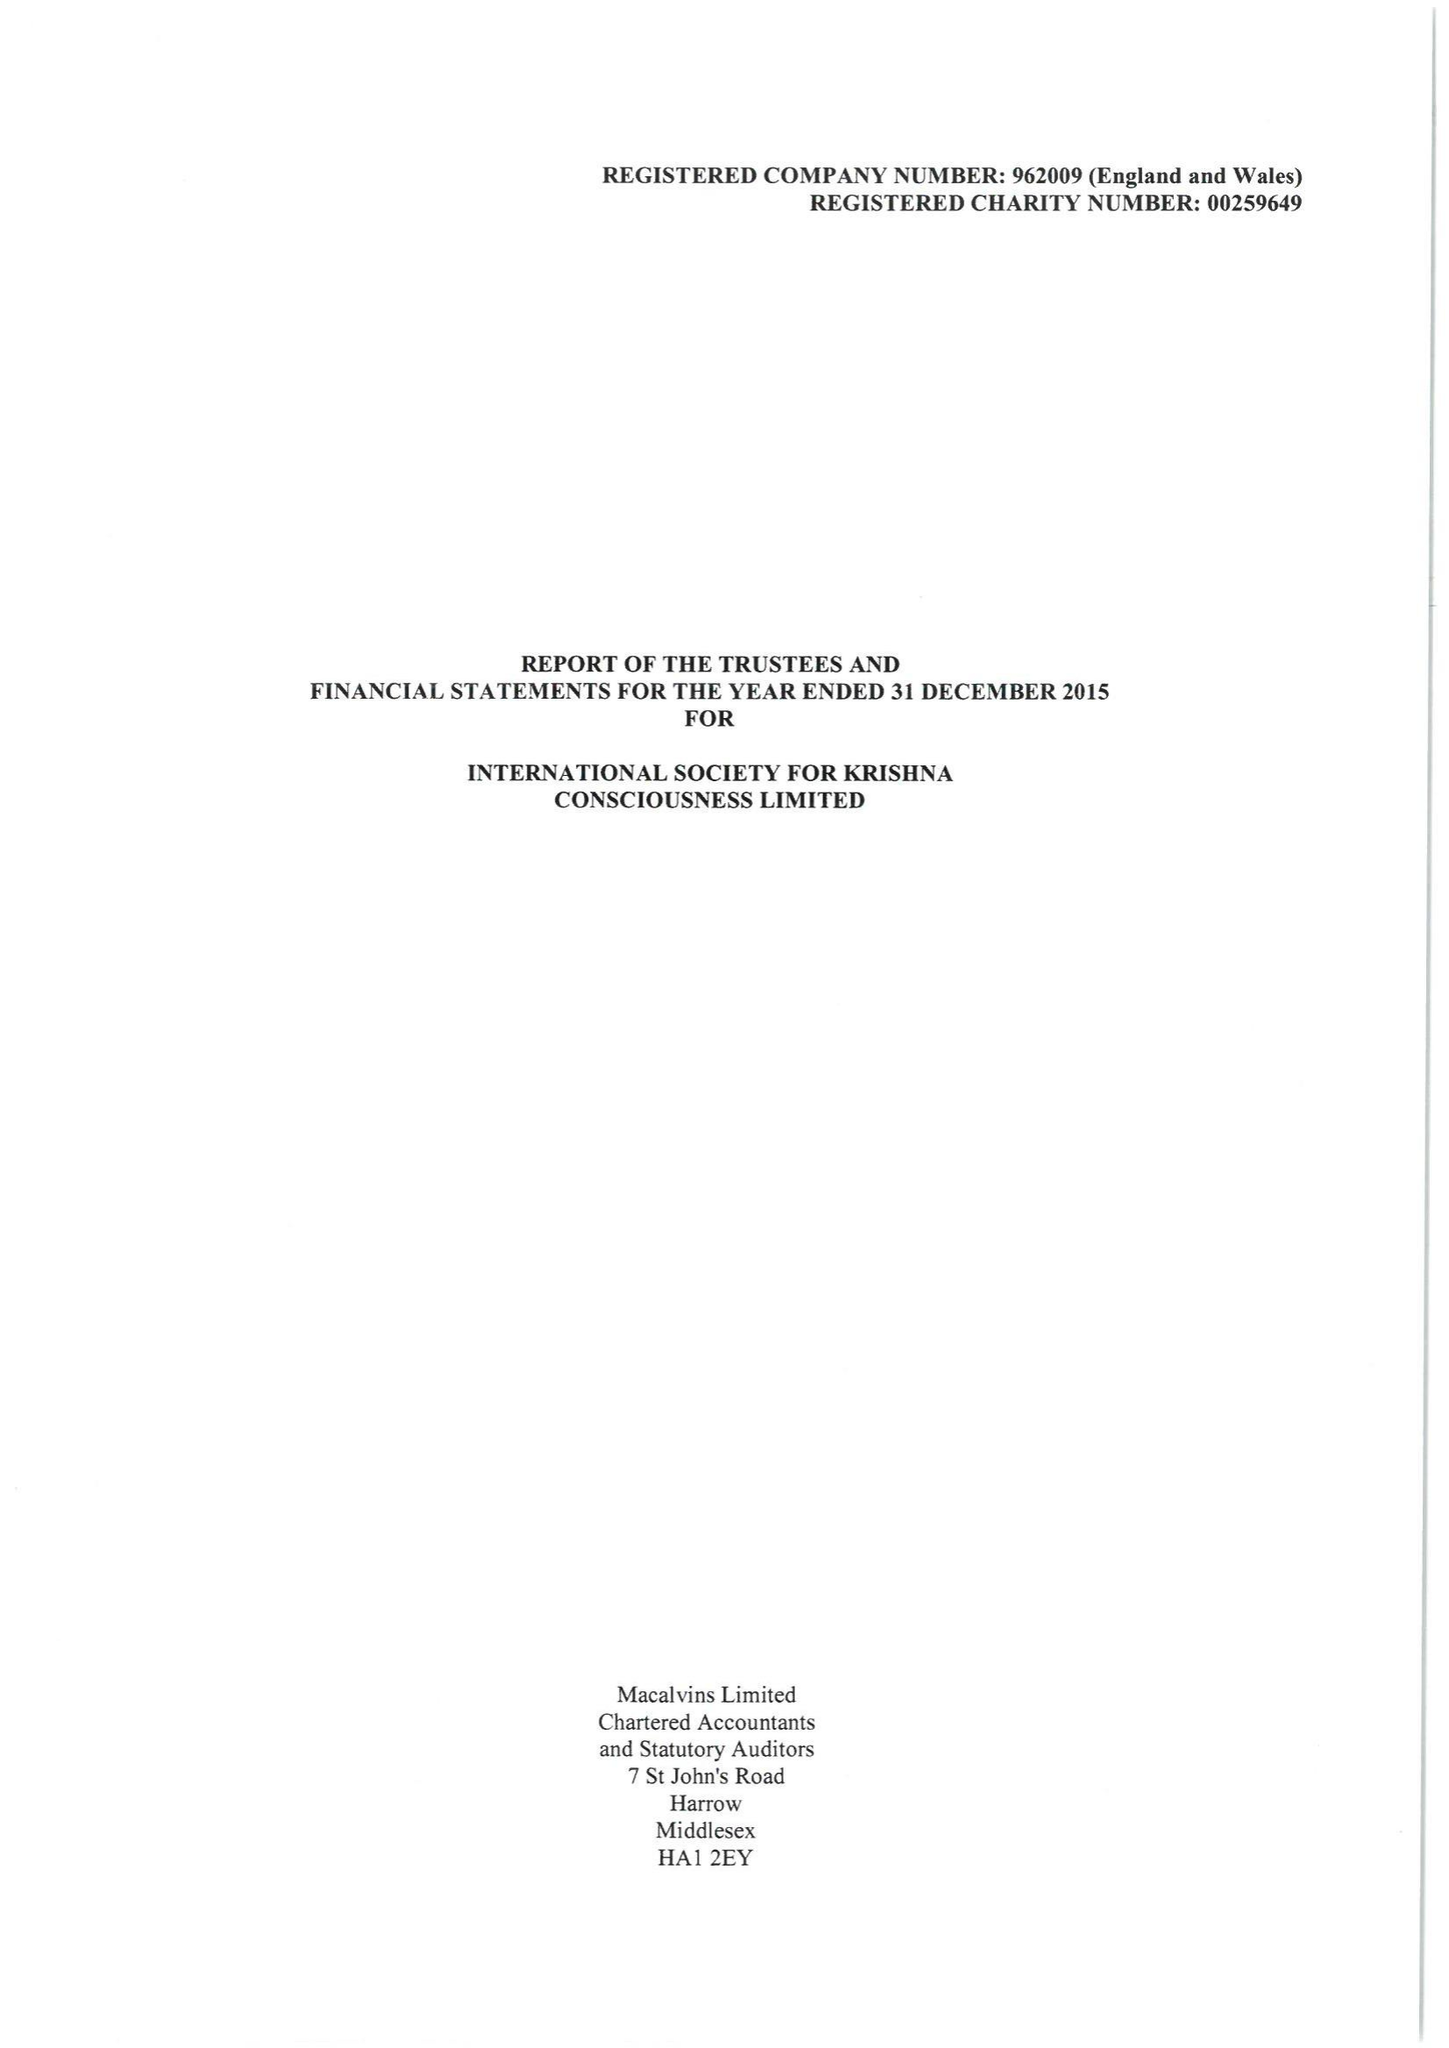What is the value for the address__street_line?
Answer the question using a single word or phrase. 1 WATFORD ROAD 